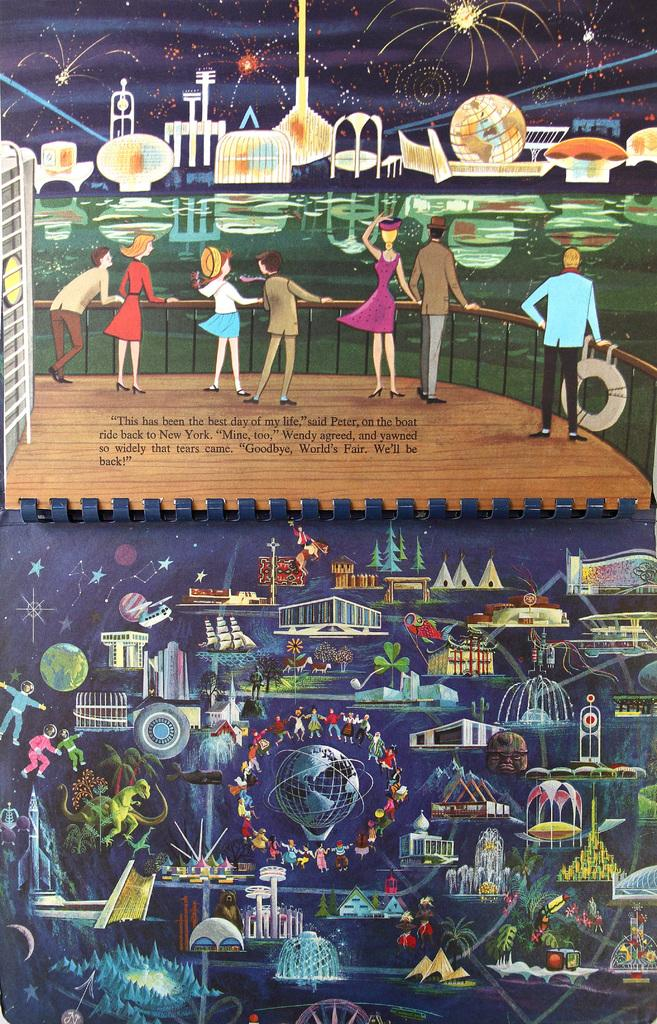<image>
Provide a brief description of the given image. A book showing animated scenes from the World's Fair, with a caption that says goodbye World's Fair, we will be back. 